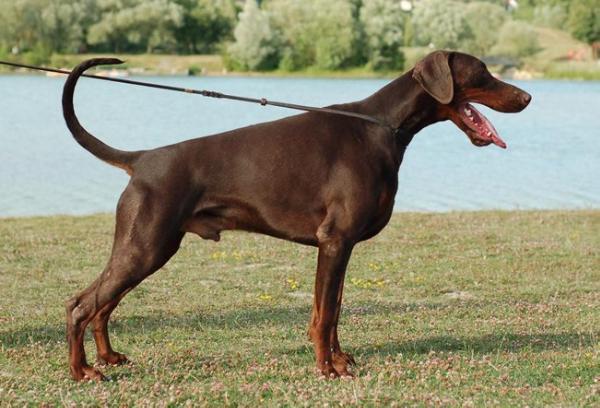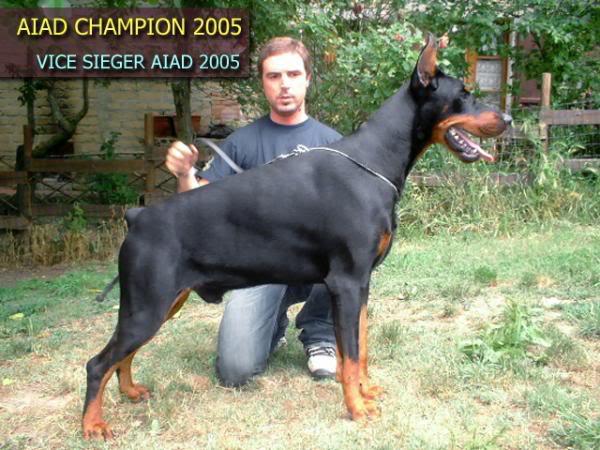The first image is the image on the left, the second image is the image on the right. Examine the images to the left and right. Is the description "At least one dog is facing towards the left." accurate? Answer yes or no. No. The first image is the image on the left, the second image is the image on the right. For the images displayed, is the sentence "Each image shows one dog standing in profile, and the left image shows a brown dog, while the right image shows a right-facing doberman with pointy ears and docked tail." factually correct? Answer yes or no. Yes. 